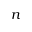<formula> <loc_0><loc_0><loc_500><loc_500>n</formula> 